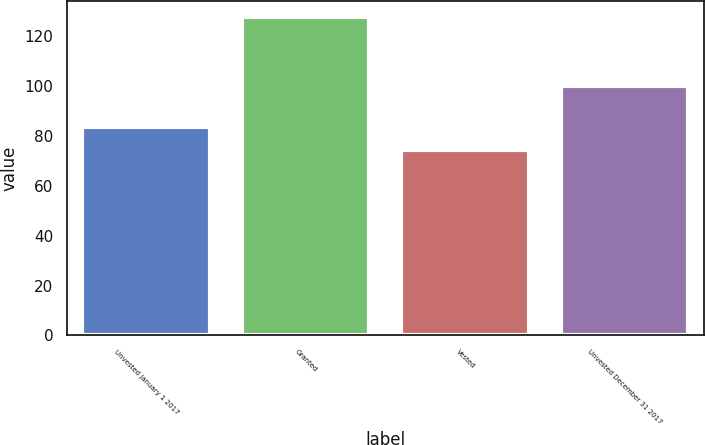<chart> <loc_0><loc_0><loc_500><loc_500><bar_chart><fcel>Unvested January 1 2017<fcel>Granted<fcel>Vested<fcel>Unvested December 31 2017<nl><fcel>83.39<fcel>127.81<fcel>74.29<fcel>99.87<nl></chart> 